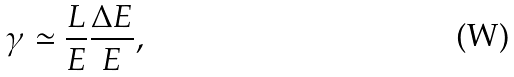<formula> <loc_0><loc_0><loc_500><loc_500>\gamma \simeq \frac { L } { E } \frac { \Delta E } { E } ,</formula> 